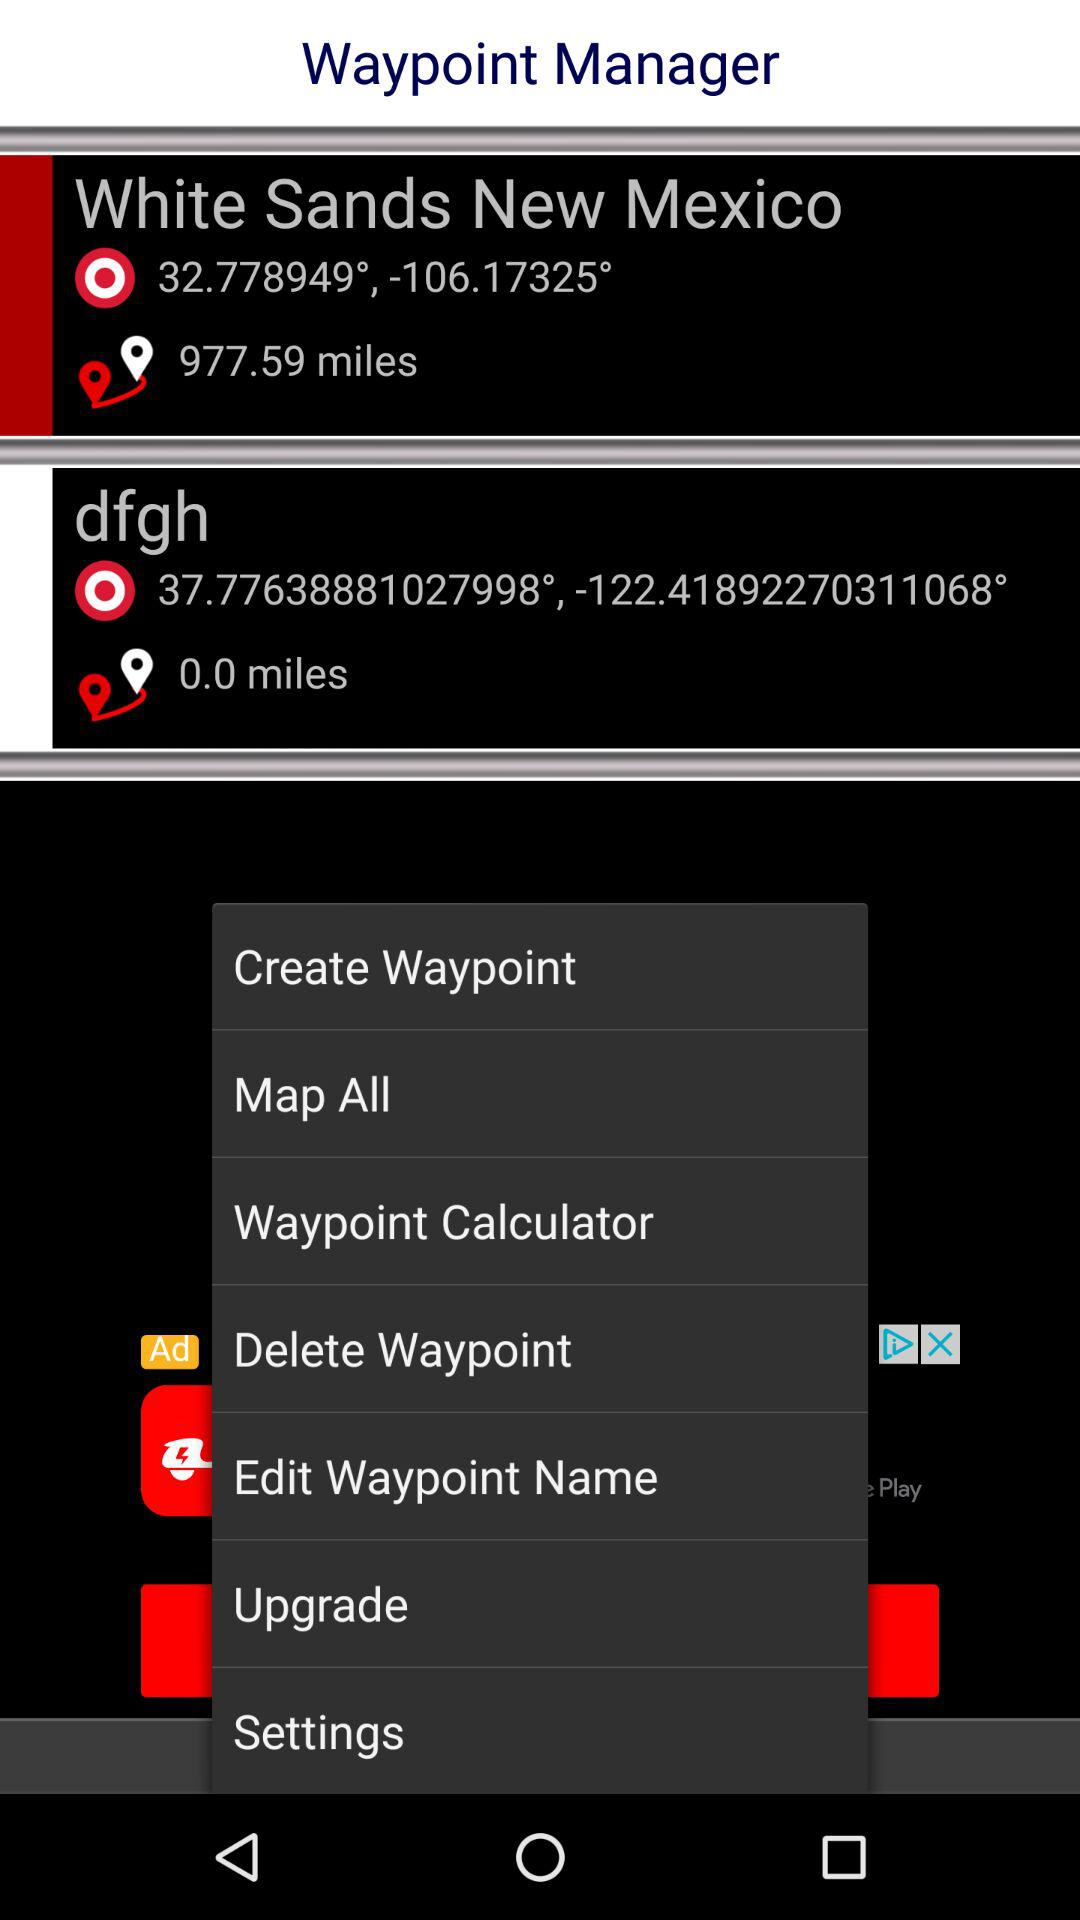What is the distance to White Sands, New Mexico? The distance to White Sands, New Mexico is 977.59 miles. 